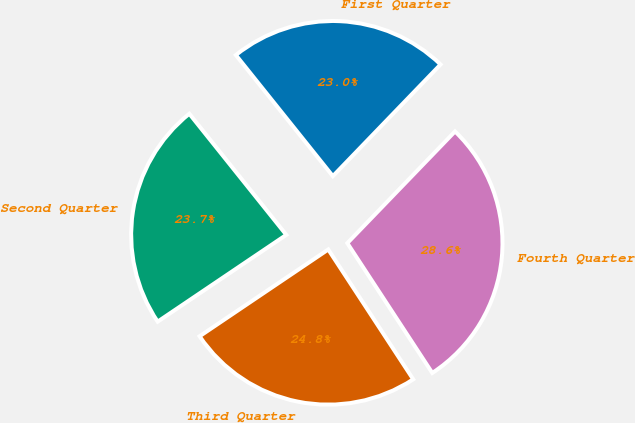Convert chart. <chart><loc_0><loc_0><loc_500><loc_500><pie_chart><fcel>First Quarter<fcel>Second Quarter<fcel>Third Quarter<fcel>Fourth Quarter<nl><fcel>22.96%<fcel>23.7%<fcel>24.78%<fcel>28.57%<nl></chart> 